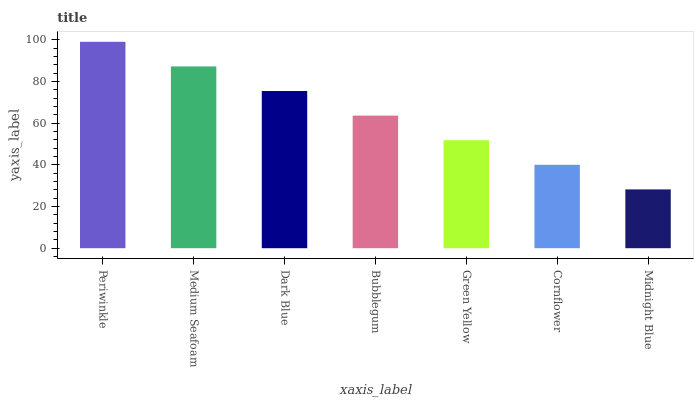Is Medium Seafoam the minimum?
Answer yes or no. No. Is Medium Seafoam the maximum?
Answer yes or no. No. Is Periwinkle greater than Medium Seafoam?
Answer yes or no. Yes. Is Medium Seafoam less than Periwinkle?
Answer yes or no. Yes. Is Medium Seafoam greater than Periwinkle?
Answer yes or no. No. Is Periwinkle less than Medium Seafoam?
Answer yes or no. No. Is Bubblegum the high median?
Answer yes or no. Yes. Is Bubblegum the low median?
Answer yes or no. Yes. Is Dark Blue the high median?
Answer yes or no. No. Is Midnight Blue the low median?
Answer yes or no. No. 